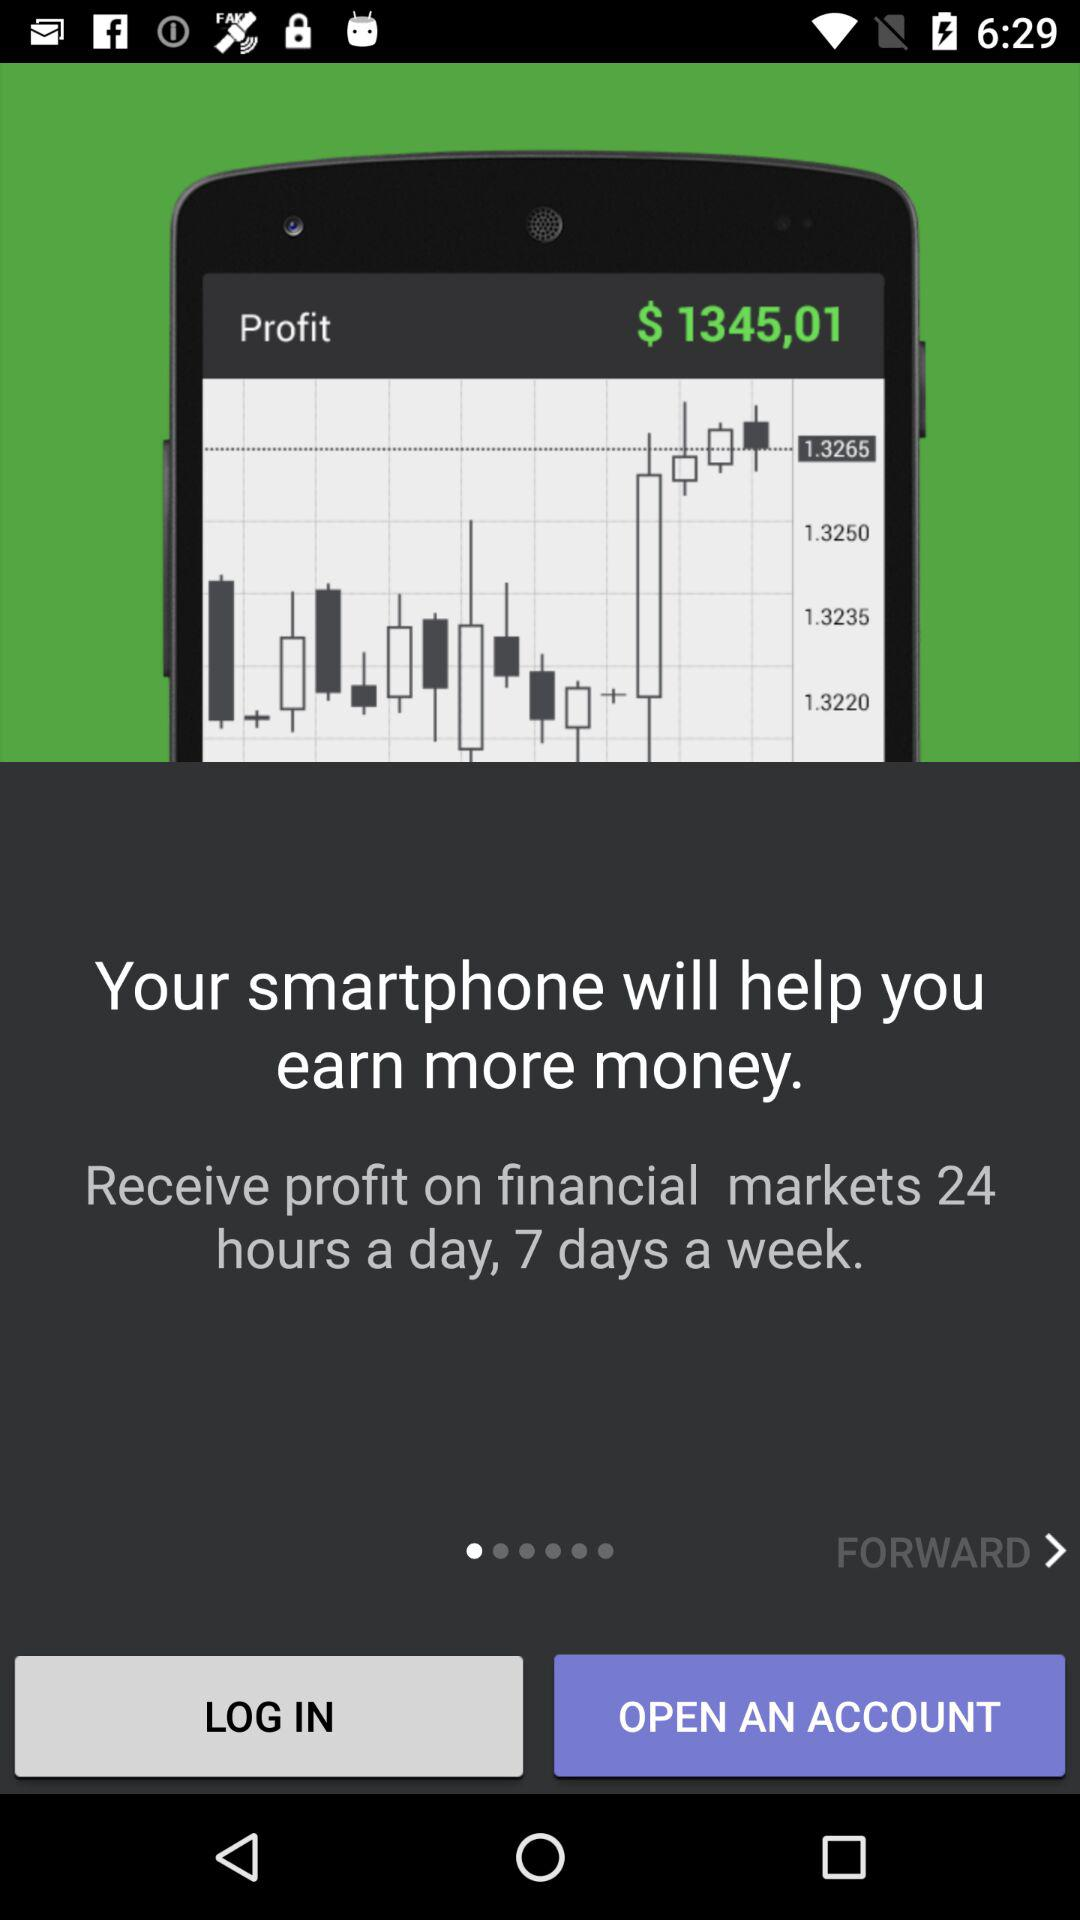What is the profit? The profit is $1345,01. 